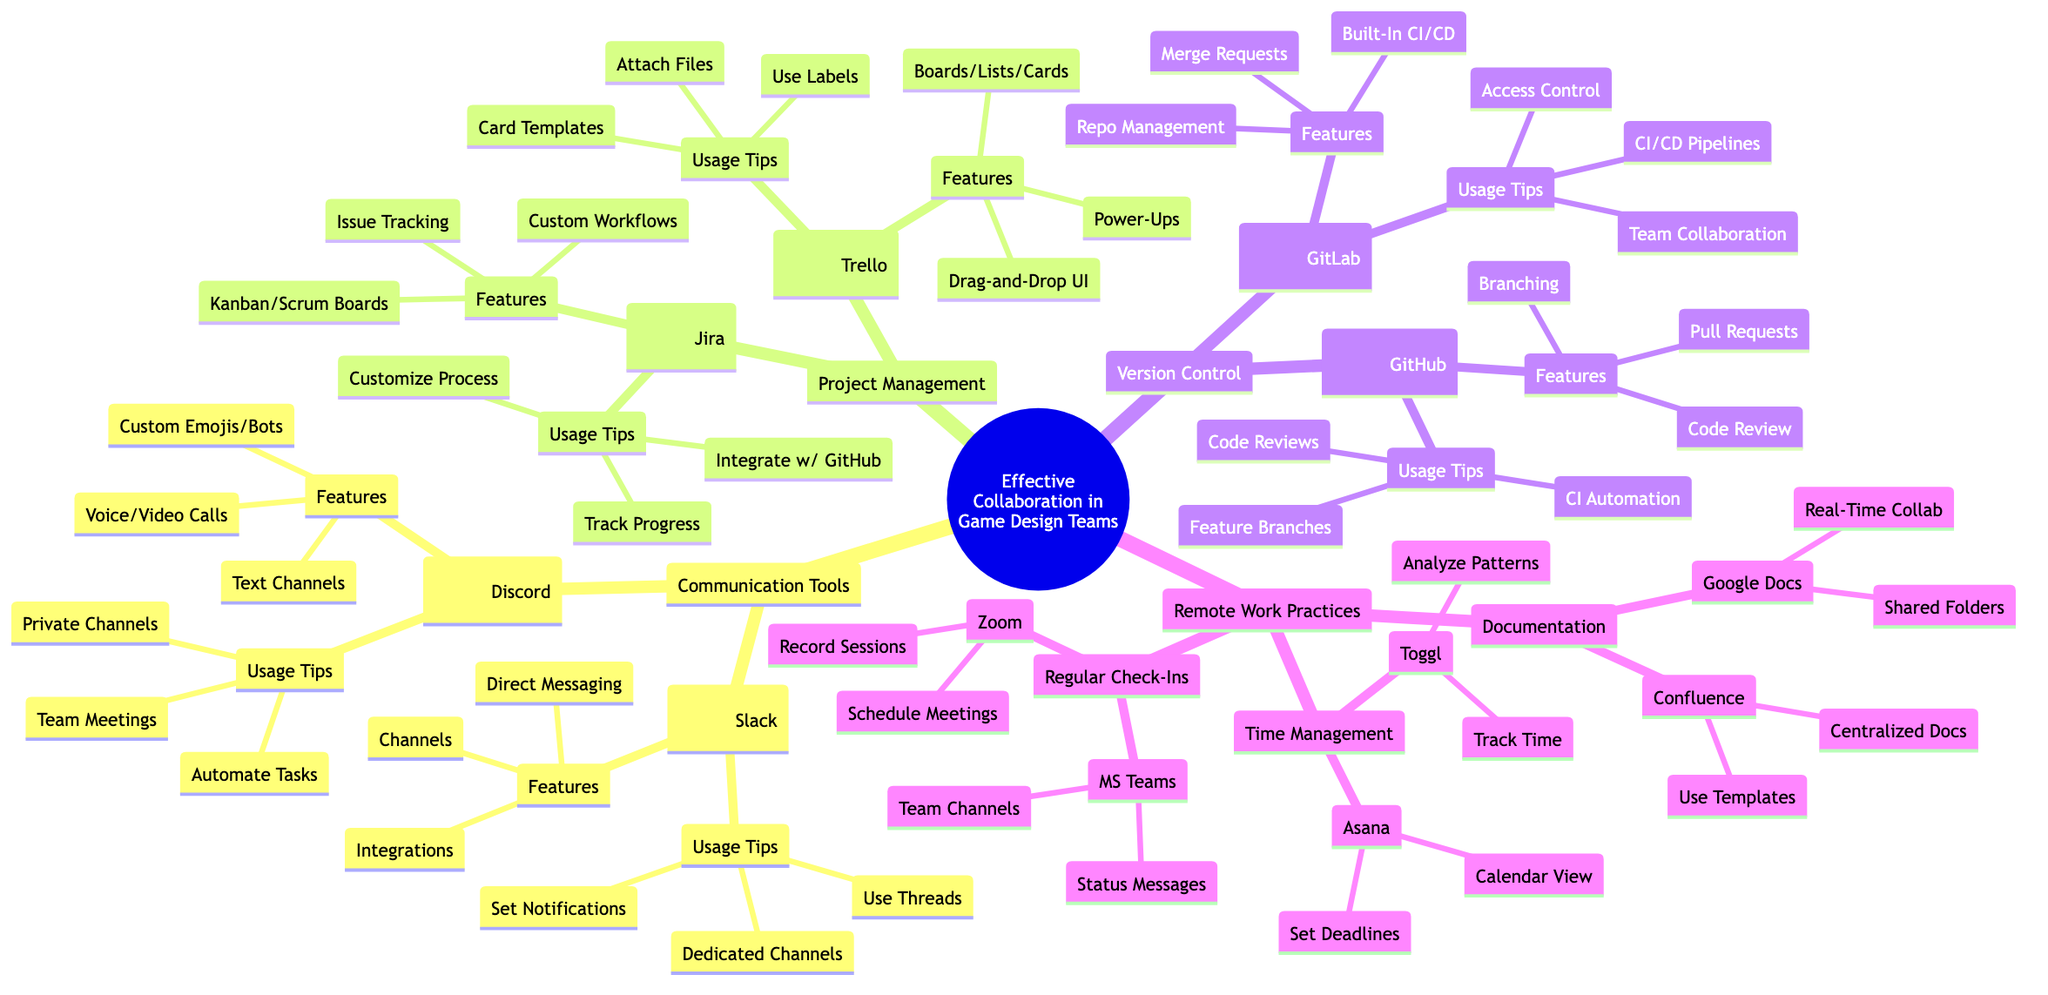What are the two communication tools listed? In the communication tools section of the diagram, there are two main tools mentioned: Slack and Discord. These tools are visually grouped under the "Communication Tools" category, indicating their role in facilitating discussions within game design teams.
Answer: Slack and Discord How many features does Slack have? The diagram under the Slack node lists three features, which are "Channels for Organized Discussions," "Direct Messaging," and "Integrations with Other Tools." Each feature is presented as a separate item listed under Slack, prompting the conclusion.
Answer: Three Which project management software integrates with GitHub? The diagram indicates that Jira integrates with GitHub as one of its usage tips under the project management section. This integration helps teams streamline their workflows by connecting task management and code repositories.
Answer: Jira What is a primary usage tip for GitLab? According to the usage tips listed under the GitLab node, a primary recommendation is to "Leverage CI/CD Pipelines for Efficient Testing and Deployment." This tip emphasizes the importance of using CI/CD processes to ensure a smooth flow from development to deployment.
Answer: Leverage CI/CD Pipelines for Efficient Testing and Deployment How many tools are recommended for time management? In the time management section of the diagram, two tools are mentioned: Toggl and Asana. Each tool is also paired with specific usage tips, indicating the support they provide for effective time management strategies in game design teams.
Answer: Two What feature of Discord allows for automation? The "Custom Emojis and Bots" feature of Discord mentioned in the diagram allows for automation. This feature is highlighted under the "Features" section for Discord and enables teams to streamline certain tasks through the use of bots.
Answer: Custom Emojis and Bots Which tool is recommended for centralized documentation? The diagram specifies that Confluence is the recommended tool for creating centralized documentation under the "Documentation" node. This recommendation signifies its important role in providing accessible information for team members.
Answer: Confluence What are two tools mentioned for regular check-ins? The two tools recommended for regular check-ins are Zoom and Microsoft Teams, stated in the "Regular Check-Ins" section of the diagram. Both tools offer capabilities that facilitate team communication and meeting organization.
Answer: Zoom and Microsoft Teams 